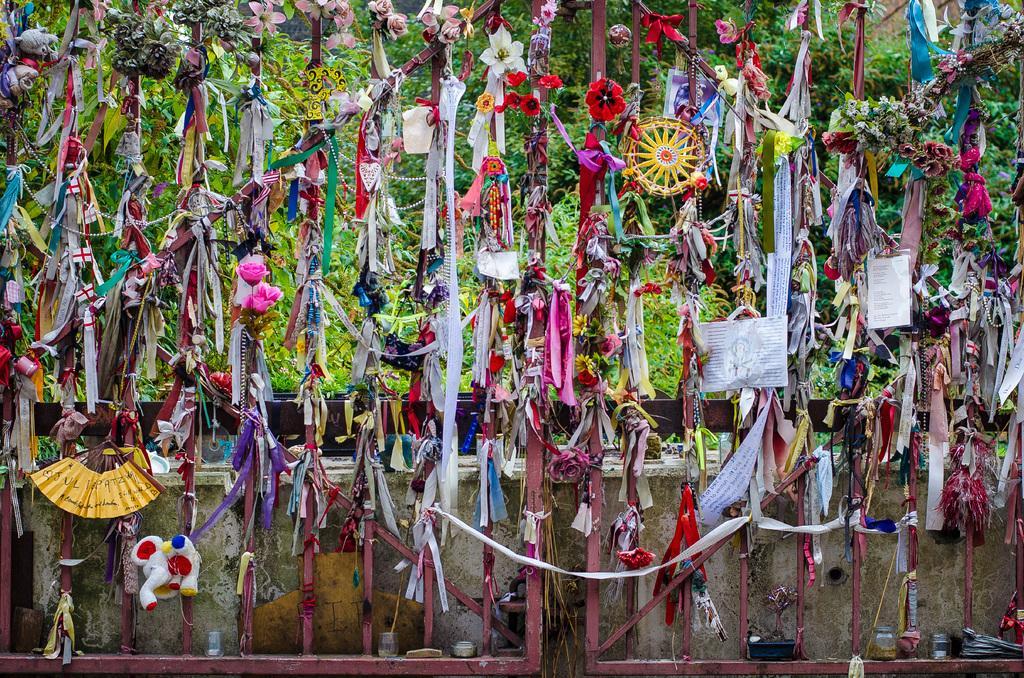In one or two sentences, can you explain what this image depicts? In this image we can see the iron gates and there are some objects like flowers, papers with some text, ribbons and some other things attached to the gates. In the background, we can see some trees. 